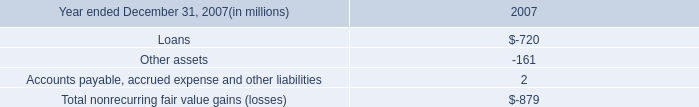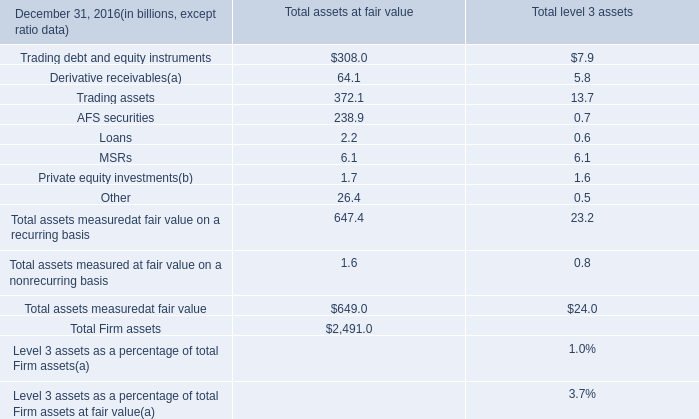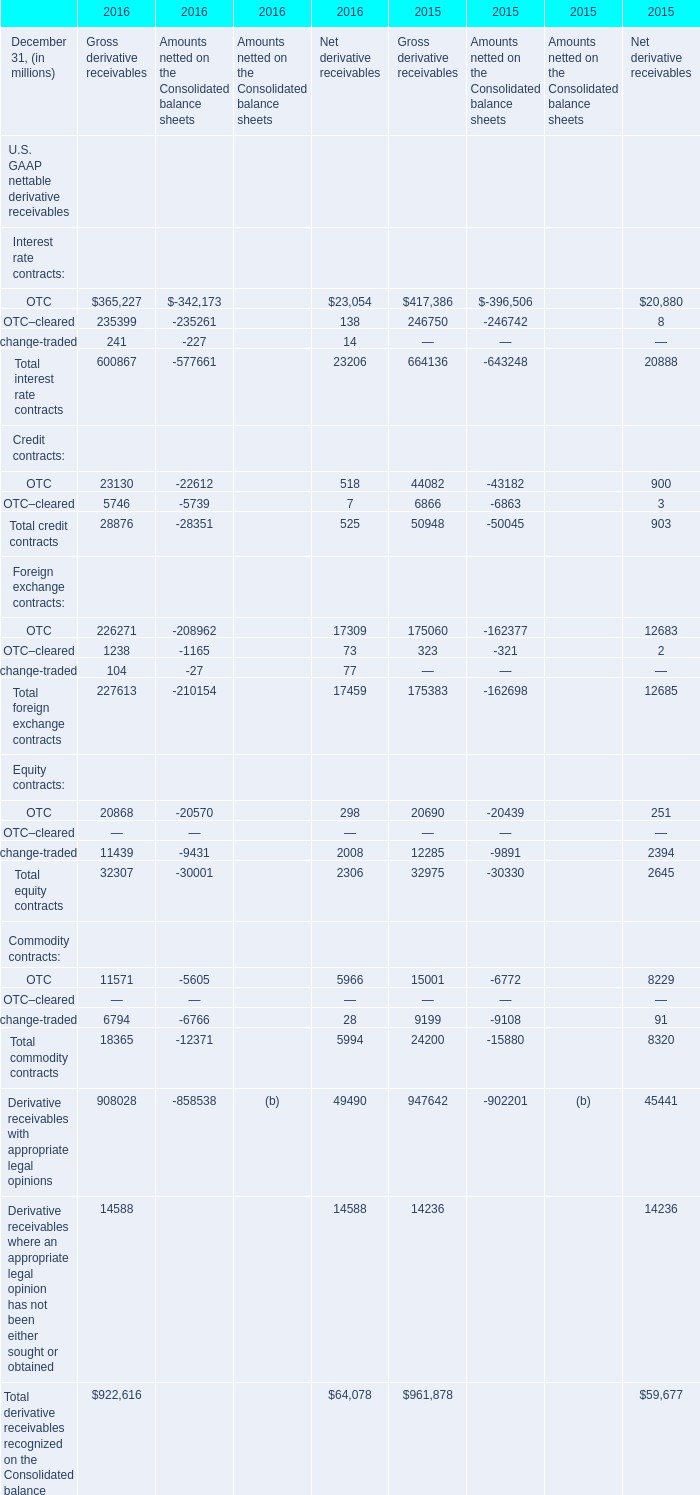What's the sum of all Amounts netted on the Consolidated balance sheets that are positive in 2016 for Interest rate contracts? 
Answer: 0. 